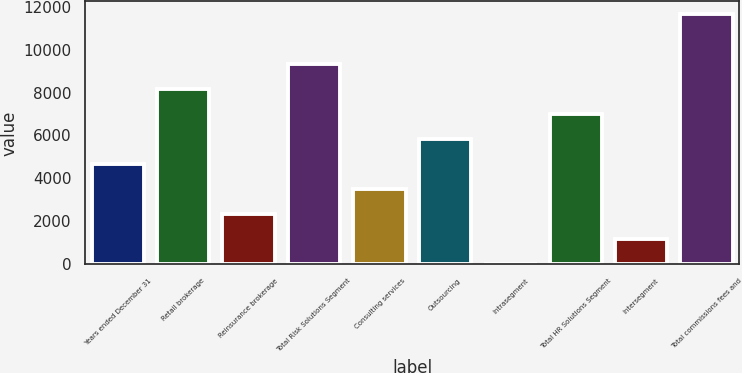<chart> <loc_0><loc_0><loc_500><loc_500><bar_chart><fcel>Years ended December 31<fcel>Retail brokerage<fcel>Reinsurance brokerage<fcel>Total Risk Solutions Segment<fcel>Consulting services<fcel>Outsourcing<fcel>Intrasegment<fcel>Total HR Solutions Segment<fcel>Intersegment<fcel>Total commissions fees and<nl><fcel>4689<fcel>8175<fcel>2365<fcel>9337<fcel>3527<fcel>5851<fcel>41<fcel>7013<fcel>1203<fcel>11661<nl></chart> 